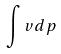Convert formula to latex. <formula><loc_0><loc_0><loc_500><loc_500>\int v d p</formula> 